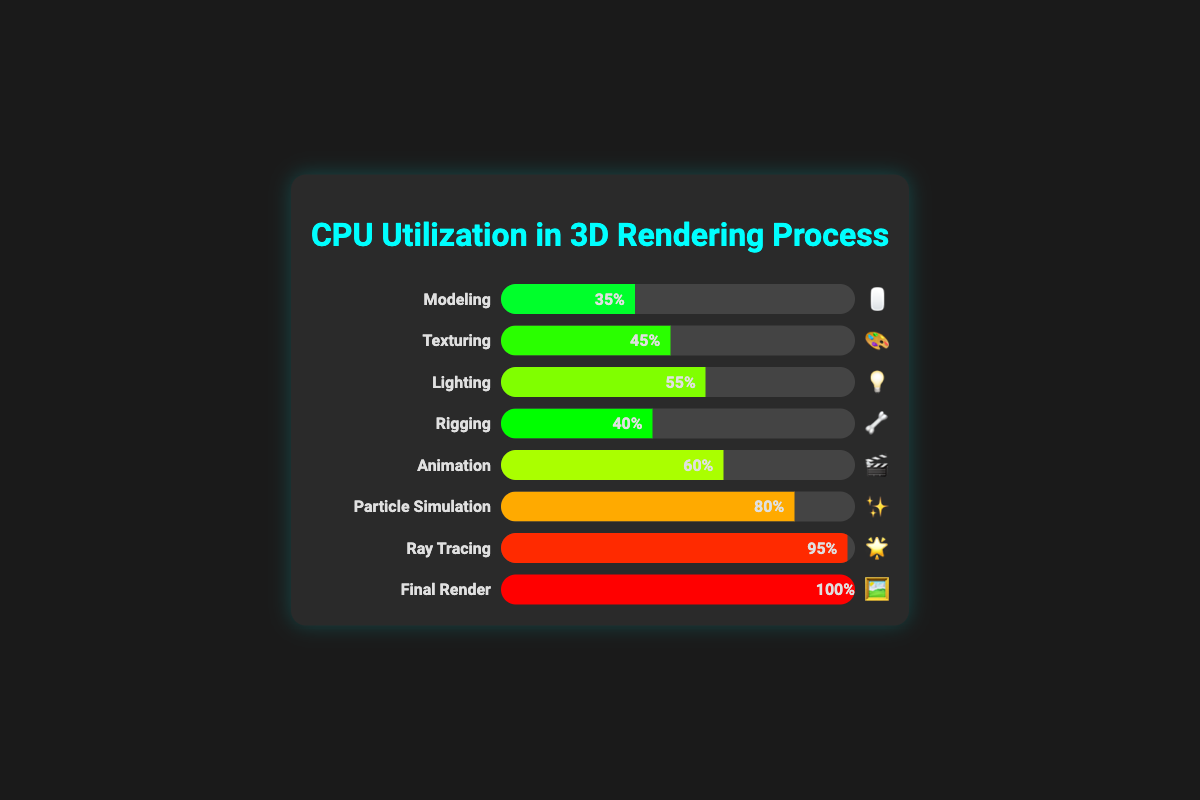Which stage has the highest CPU utilization? The figure shows the CPU utilization at different stages of the 3D rendering process. The "Final Render" stage has the highest CPU utilization shown by a 100% filled progress bar.
Answer: Final Render What is the CPU utilization during the Texturing stage? In the chart, the Texturing stage is represented with a progress bar at 45% utilization next to the "Texturing" label and emoji "🎨."
Answer: 45% Which stage uses more CPU, Animation or Rigging? The Animation stage has a CPU utilization of 60%, while Rigging has 40%, shown by their respective progress bars. Thus, Animation uses more.
Answer: Animation How much more CPU does Particle Simulation use compared to Modeling? The CPU utilization for Particle Simulation is 80%, and for Modeling, it is 35%. The difference between them can be calculated by 80% - 35% = 45%.
Answer: 45% What is the average CPU utilization across all stages? Add up the CPU utilizations and divide by the number of stages: (35 + 45 + 55 + 40 + 60 + 80 + 95 + 100) / 8. This equals 510 / 8 = 63.75%.
Answer: 63.75% Which stages have a CPU utilization higher than 50%? From the chart, the stages with CPU utilization higher than 50% are "Lighting" (55%), "Animation" (60%), "Particle Simulation" (80%), "Ray Tracing" (95%), and "Final Render" (100%).
Answer: Lighting, Animation, Particle Simulation, Ray Tracing, Final Render Does the Lighting stage have higher or lower CPU utilization compared to the Texturing stage? The chart shows 55% CPU utilization for Lighting and 45% for Texturing. Therefore, Lighting has a higher CPU utilization.
Answer: Higher What is the total CPU utilization percentage for Modeling, Rigging, and Animation stages combined? Summing these stages' CPU utilizations: 35% (Modeling) + 40% (Rigging) + 60% (Animation) = 135%.
Answer: 135% Which emoji represents Ray Tracing? The chart uses emojis for each stage, and the emoji for the Ray Tracing stage is "🌟".
Answer: 🌟 